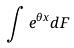<formula> <loc_0><loc_0><loc_500><loc_500>\int e ^ { \theta x } d F</formula> 